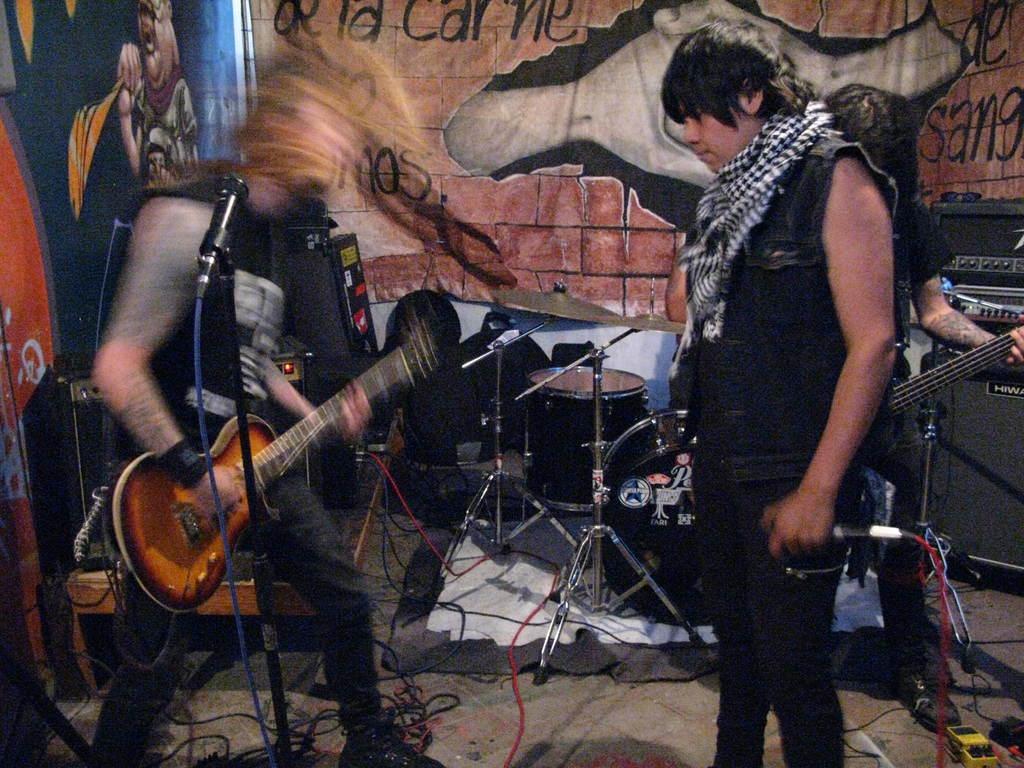Describe this image in one or two sentences. In this image we have group of people who are standing, among them the person on the left side is playing a guitar in front of the microphone. Here we have few drums. In the background we have a wall which is painted. 